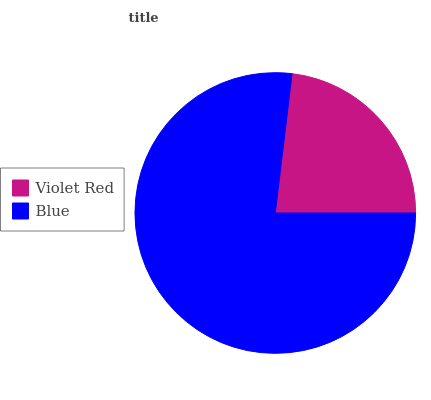Is Violet Red the minimum?
Answer yes or no. Yes. Is Blue the maximum?
Answer yes or no. Yes. Is Blue the minimum?
Answer yes or no. No. Is Blue greater than Violet Red?
Answer yes or no. Yes. Is Violet Red less than Blue?
Answer yes or no. Yes. Is Violet Red greater than Blue?
Answer yes or no. No. Is Blue less than Violet Red?
Answer yes or no. No. Is Blue the high median?
Answer yes or no. Yes. Is Violet Red the low median?
Answer yes or no. Yes. Is Violet Red the high median?
Answer yes or no. No. Is Blue the low median?
Answer yes or no. No. 